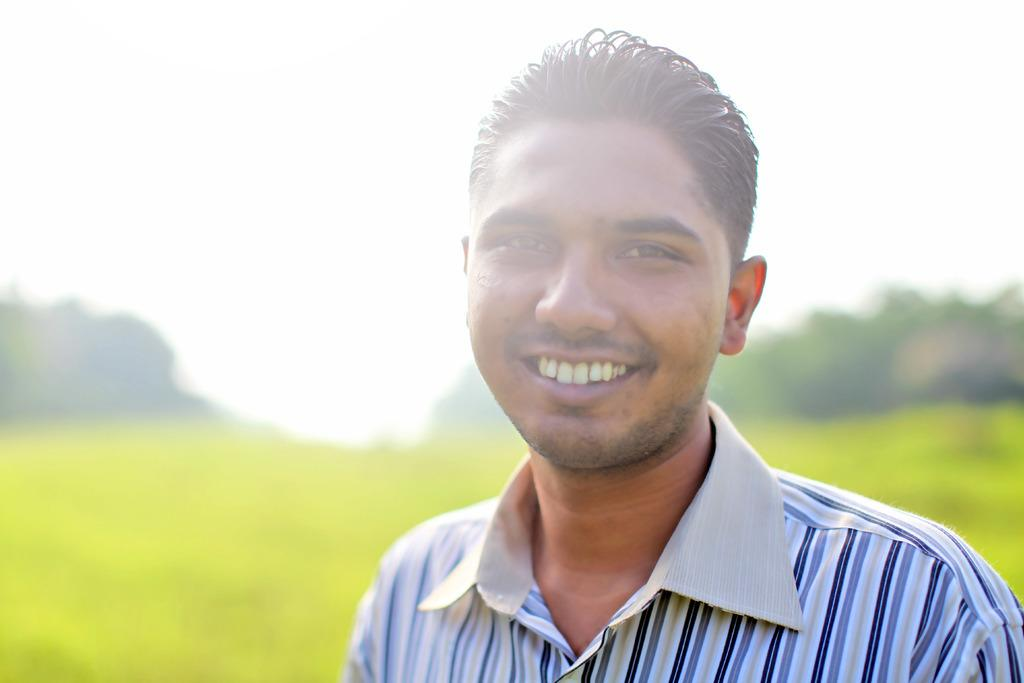Who is present in the image? There is a man in the picture. What is the man wearing? The man is wearing a shirt. What expression does the man have? The man is smiling. What can be seen in the background of the image? Farmland and trees are visible in the background of the image. What is visible at the top of the image? The sky is visible at the top of the image. What type of wine is the man drinking in the image? There is no wine present in the image; the man is simply smiling. Can you see any toads in the image? There are no toads present in the image. 